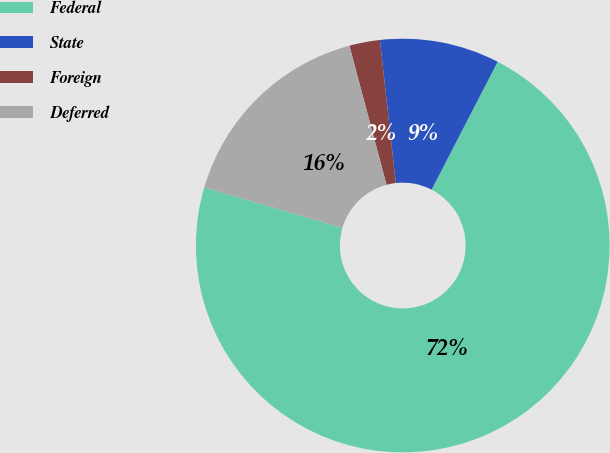Convert chart to OTSL. <chart><loc_0><loc_0><loc_500><loc_500><pie_chart><fcel>Federal<fcel>State<fcel>Foreign<fcel>Deferred<nl><fcel>71.95%<fcel>9.35%<fcel>2.39%<fcel>16.31%<nl></chart> 